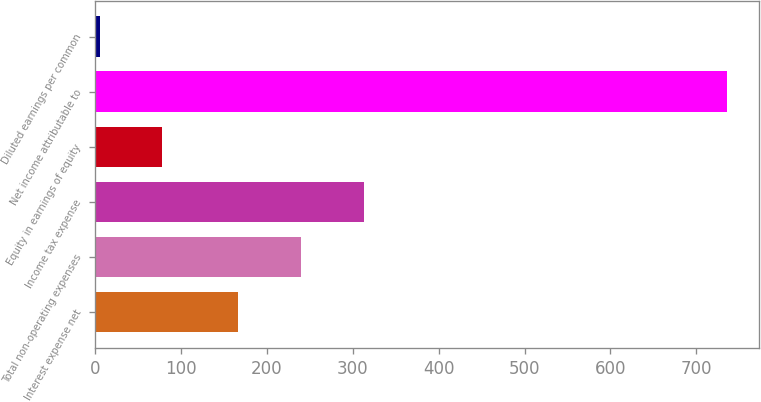<chart> <loc_0><loc_0><loc_500><loc_500><bar_chart><fcel>Interest expense net<fcel>Total non-operating expenses<fcel>Income tax expense<fcel>Equity in earnings of equity<fcel>Net income attributable to<fcel>Diluted earnings per common<nl><fcel>167<fcel>240.07<fcel>313.14<fcel>78.36<fcel>736<fcel>5.29<nl></chart> 